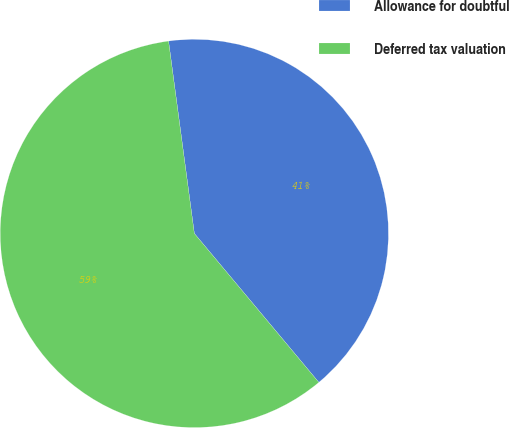Convert chart to OTSL. <chart><loc_0><loc_0><loc_500><loc_500><pie_chart><fcel>Allowance for doubtful<fcel>Deferred tax valuation<nl><fcel>41.04%<fcel>58.96%<nl></chart> 